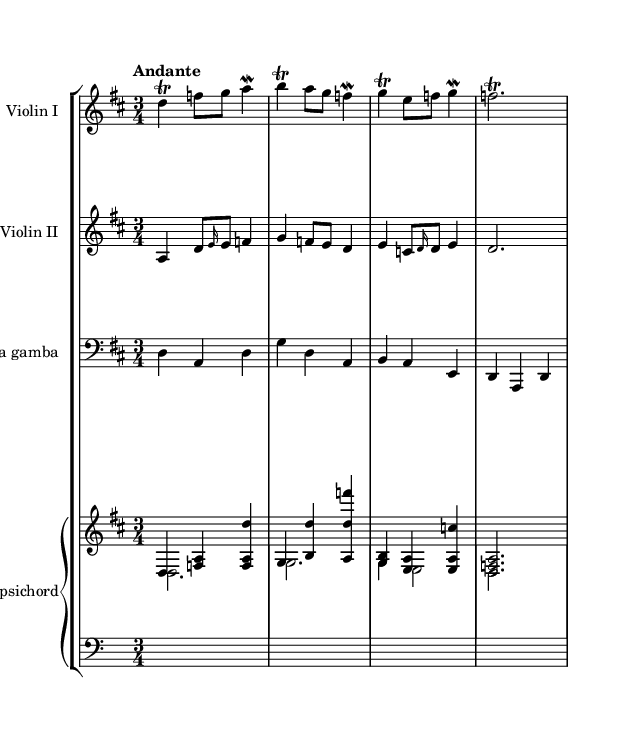What is the key signature of this music? The key signature displayed is D major, which has two sharps (F# and C#). This can be identified in the beginning of the staff, where the sharps are shown before the note names.
Answer: D major What is the time signature of this music? The time signature shown is 3/4, which indicates there are three beats in a measure, and the quarter note gets one beat. This is typically found at the beginning of the score.
Answer: 3/4 What is the tempo marking for this piece? The tempo marking states "Andante," indicating a moderately slow tempo. This word is typically placed above the staff to guide the performers on the music's pacing.
Answer: Andante How many instruments are featured in this piece? The score includes four instruments: two violins (Violin I and Violin II), a viola da gamba, and a harpsichord. This can be determined by counting the unique staves for each instrument in the staff group.
Answer: Four Which instrument plays the highest notes? The instrument playing the highest notes is Violin I. By examining the range of notes and their respective staffs, it is clear that the pitches played in Violin I are higher than those in the other instruments.
Answer: Violin I What kind of ornamentation is used in this music? The music features trills and mordents, indicated by specific markings next to the notes. These are characteristic of Baroque ornamentation, enhancing expressiveness in the performance.
Answer: Trills and mordents What is the form of this chamber music? The form of this piece can be identified as a suite or sonata due to its stylistic elements, characterized by dance patterns and sections, a common structure in Baroque chamber music.
Answer: Suite or sonata 